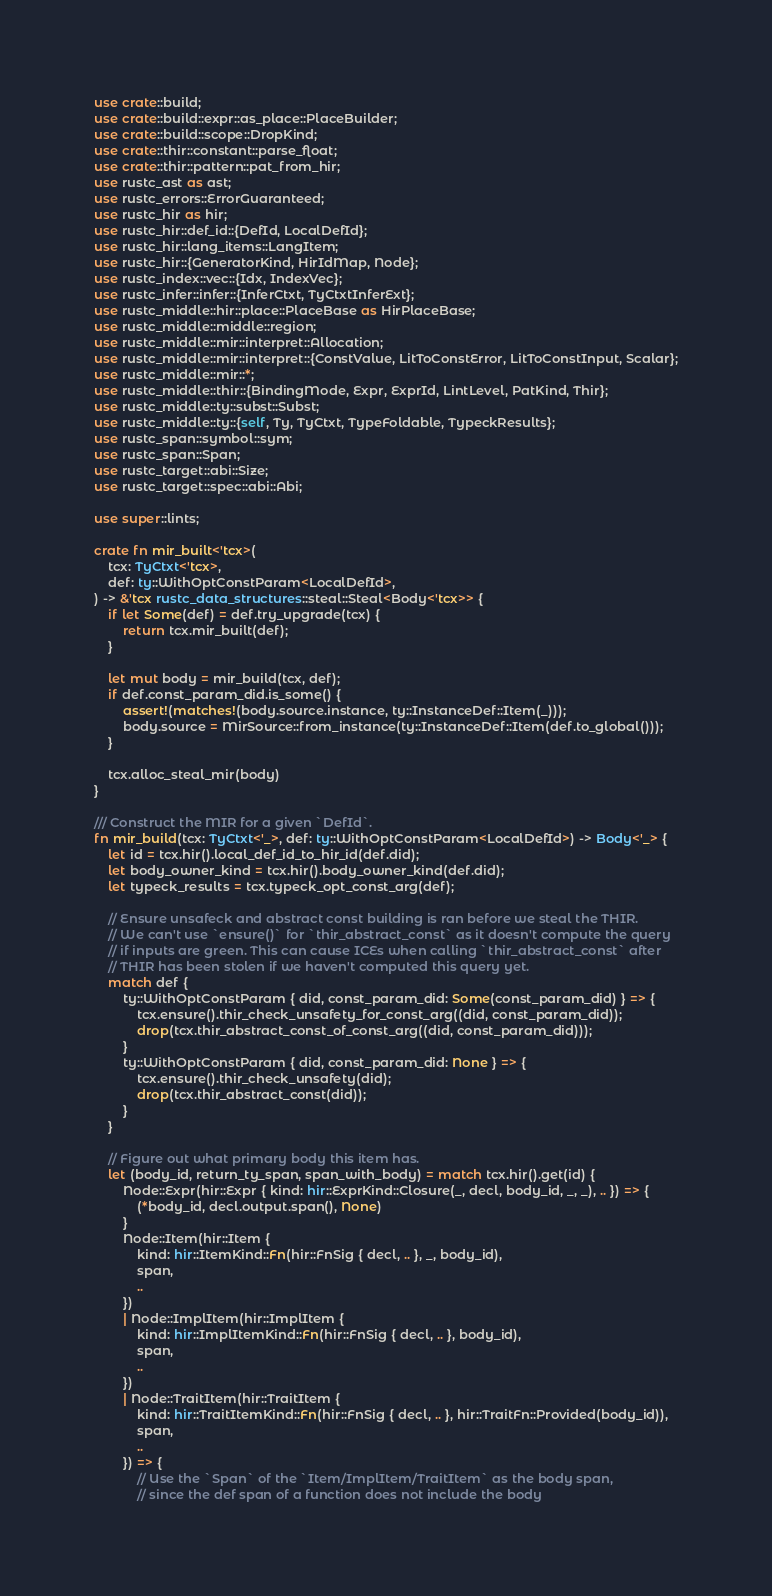Convert code to text. <code><loc_0><loc_0><loc_500><loc_500><_Rust_>use crate::build;
use crate::build::expr::as_place::PlaceBuilder;
use crate::build::scope::DropKind;
use crate::thir::constant::parse_float;
use crate::thir::pattern::pat_from_hir;
use rustc_ast as ast;
use rustc_errors::ErrorGuaranteed;
use rustc_hir as hir;
use rustc_hir::def_id::{DefId, LocalDefId};
use rustc_hir::lang_items::LangItem;
use rustc_hir::{GeneratorKind, HirIdMap, Node};
use rustc_index::vec::{Idx, IndexVec};
use rustc_infer::infer::{InferCtxt, TyCtxtInferExt};
use rustc_middle::hir::place::PlaceBase as HirPlaceBase;
use rustc_middle::middle::region;
use rustc_middle::mir::interpret::Allocation;
use rustc_middle::mir::interpret::{ConstValue, LitToConstError, LitToConstInput, Scalar};
use rustc_middle::mir::*;
use rustc_middle::thir::{BindingMode, Expr, ExprId, LintLevel, PatKind, Thir};
use rustc_middle::ty::subst::Subst;
use rustc_middle::ty::{self, Ty, TyCtxt, TypeFoldable, TypeckResults};
use rustc_span::symbol::sym;
use rustc_span::Span;
use rustc_target::abi::Size;
use rustc_target::spec::abi::Abi;

use super::lints;

crate fn mir_built<'tcx>(
    tcx: TyCtxt<'tcx>,
    def: ty::WithOptConstParam<LocalDefId>,
) -> &'tcx rustc_data_structures::steal::Steal<Body<'tcx>> {
    if let Some(def) = def.try_upgrade(tcx) {
        return tcx.mir_built(def);
    }

    let mut body = mir_build(tcx, def);
    if def.const_param_did.is_some() {
        assert!(matches!(body.source.instance, ty::InstanceDef::Item(_)));
        body.source = MirSource::from_instance(ty::InstanceDef::Item(def.to_global()));
    }

    tcx.alloc_steal_mir(body)
}

/// Construct the MIR for a given `DefId`.
fn mir_build(tcx: TyCtxt<'_>, def: ty::WithOptConstParam<LocalDefId>) -> Body<'_> {
    let id = tcx.hir().local_def_id_to_hir_id(def.did);
    let body_owner_kind = tcx.hir().body_owner_kind(def.did);
    let typeck_results = tcx.typeck_opt_const_arg(def);

    // Ensure unsafeck and abstract const building is ran before we steal the THIR.
    // We can't use `ensure()` for `thir_abstract_const` as it doesn't compute the query
    // if inputs are green. This can cause ICEs when calling `thir_abstract_const` after
    // THIR has been stolen if we haven't computed this query yet.
    match def {
        ty::WithOptConstParam { did, const_param_did: Some(const_param_did) } => {
            tcx.ensure().thir_check_unsafety_for_const_arg((did, const_param_did));
            drop(tcx.thir_abstract_const_of_const_arg((did, const_param_did)));
        }
        ty::WithOptConstParam { did, const_param_did: None } => {
            tcx.ensure().thir_check_unsafety(did);
            drop(tcx.thir_abstract_const(did));
        }
    }

    // Figure out what primary body this item has.
    let (body_id, return_ty_span, span_with_body) = match tcx.hir().get(id) {
        Node::Expr(hir::Expr { kind: hir::ExprKind::Closure(_, decl, body_id, _, _), .. }) => {
            (*body_id, decl.output.span(), None)
        }
        Node::Item(hir::Item {
            kind: hir::ItemKind::Fn(hir::FnSig { decl, .. }, _, body_id),
            span,
            ..
        })
        | Node::ImplItem(hir::ImplItem {
            kind: hir::ImplItemKind::Fn(hir::FnSig { decl, .. }, body_id),
            span,
            ..
        })
        | Node::TraitItem(hir::TraitItem {
            kind: hir::TraitItemKind::Fn(hir::FnSig { decl, .. }, hir::TraitFn::Provided(body_id)),
            span,
            ..
        }) => {
            // Use the `Span` of the `Item/ImplItem/TraitItem` as the body span,
            // since the def span of a function does not include the body</code> 